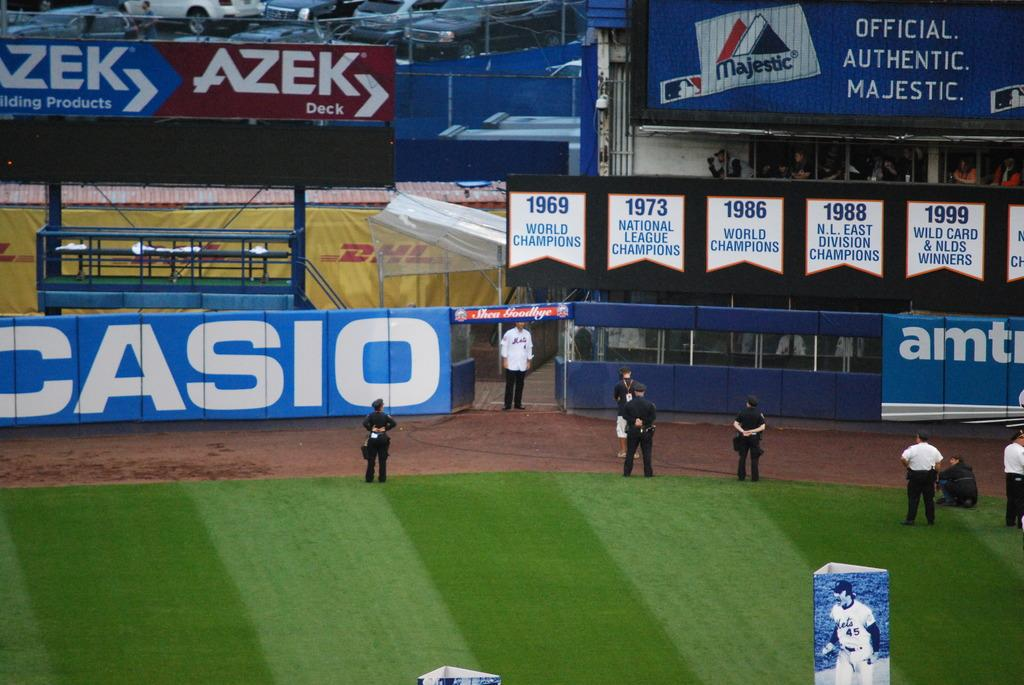<image>
Render a clear and concise summary of the photo. Baseball stadium with an ad for CASIO on the side. 